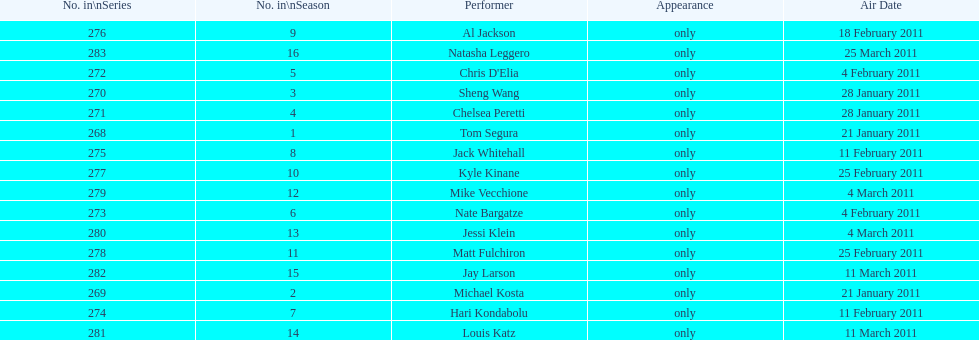Did al jackson's show happen before or after kyle kinane's? Before. 